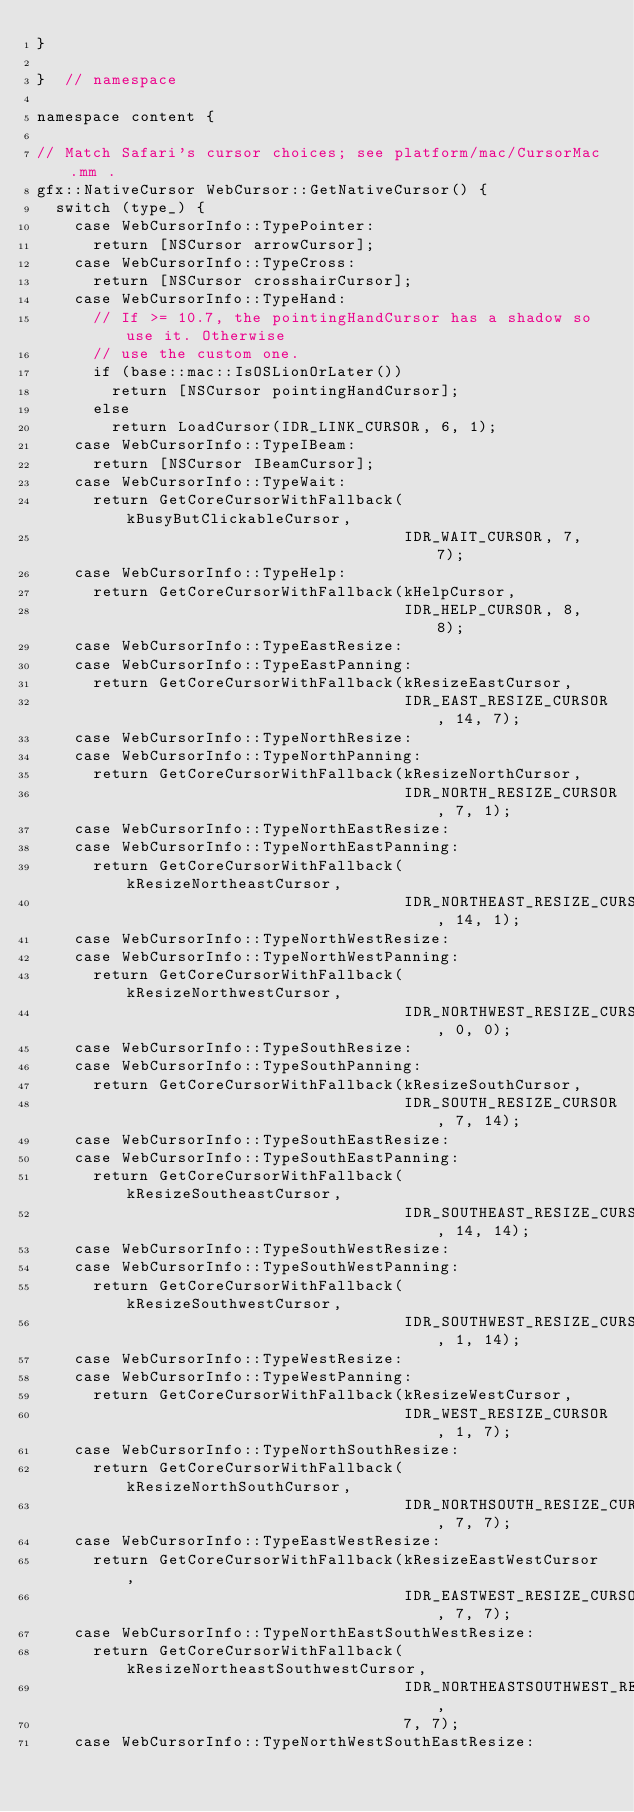Convert code to text. <code><loc_0><loc_0><loc_500><loc_500><_ObjectiveC_>}

}  // namespace

namespace content {

// Match Safari's cursor choices; see platform/mac/CursorMac.mm .
gfx::NativeCursor WebCursor::GetNativeCursor() {
  switch (type_) {
    case WebCursorInfo::TypePointer:
      return [NSCursor arrowCursor];
    case WebCursorInfo::TypeCross:
      return [NSCursor crosshairCursor];
    case WebCursorInfo::TypeHand:
      // If >= 10.7, the pointingHandCursor has a shadow so use it. Otherwise
      // use the custom one.
      if (base::mac::IsOSLionOrLater())
        return [NSCursor pointingHandCursor];
      else
        return LoadCursor(IDR_LINK_CURSOR, 6, 1);
    case WebCursorInfo::TypeIBeam:
      return [NSCursor IBeamCursor];
    case WebCursorInfo::TypeWait:
      return GetCoreCursorWithFallback(kBusyButClickableCursor,
                                       IDR_WAIT_CURSOR, 7, 7);
    case WebCursorInfo::TypeHelp:
      return GetCoreCursorWithFallback(kHelpCursor,
                                       IDR_HELP_CURSOR, 8, 8);
    case WebCursorInfo::TypeEastResize:
    case WebCursorInfo::TypeEastPanning:
      return GetCoreCursorWithFallback(kResizeEastCursor,
                                       IDR_EAST_RESIZE_CURSOR, 14, 7);
    case WebCursorInfo::TypeNorthResize:
    case WebCursorInfo::TypeNorthPanning:
      return GetCoreCursorWithFallback(kResizeNorthCursor,
                                       IDR_NORTH_RESIZE_CURSOR, 7, 1);
    case WebCursorInfo::TypeNorthEastResize:
    case WebCursorInfo::TypeNorthEastPanning:
      return GetCoreCursorWithFallback(kResizeNortheastCursor,
                                       IDR_NORTHEAST_RESIZE_CURSOR, 14, 1);
    case WebCursorInfo::TypeNorthWestResize:
    case WebCursorInfo::TypeNorthWestPanning:
      return GetCoreCursorWithFallback(kResizeNorthwestCursor,
                                       IDR_NORTHWEST_RESIZE_CURSOR, 0, 0);
    case WebCursorInfo::TypeSouthResize:
    case WebCursorInfo::TypeSouthPanning:
      return GetCoreCursorWithFallback(kResizeSouthCursor,
                                       IDR_SOUTH_RESIZE_CURSOR, 7, 14);
    case WebCursorInfo::TypeSouthEastResize:
    case WebCursorInfo::TypeSouthEastPanning:
      return GetCoreCursorWithFallback(kResizeSoutheastCursor,
                                       IDR_SOUTHEAST_RESIZE_CURSOR, 14, 14);
    case WebCursorInfo::TypeSouthWestResize:
    case WebCursorInfo::TypeSouthWestPanning:
      return GetCoreCursorWithFallback(kResizeSouthwestCursor,
                                       IDR_SOUTHWEST_RESIZE_CURSOR, 1, 14);
    case WebCursorInfo::TypeWestResize:
    case WebCursorInfo::TypeWestPanning:
      return GetCoreCursorWithFallback(kResizeWestCursor,
                                       IDR_WEST_RESIZE_CURSOR, 1, 7);
    case WebCursorInfo::TypeNorthSouthResize:
      return GetCoreCursorWithFallback(kResizeNorthSouthCursor,
                                       IDR_NORTHSOUTH_RESIZE_CURSOR, 7, 7);
    case WebCursorInfo::TypeEastWestResize:
      return GetCoreCursorWithFallback(kResizeEastWestCursor,
                                       IDR_EASTWEST_RESIZE_CURSOR, 7, 7);
    case WebCursorInfo::TypeNorthEastSouthWestResize:
      return GetCoreCursorWithFallback(kResizeNortheastSouthwestCursor,
                                       IDR_NORTHEASTSOUTHWEST_RESIZE_CURSOR,
                                       7, 7);
    case WebCursorInfo::TypeNorthWestSouthEastResize:</code> 